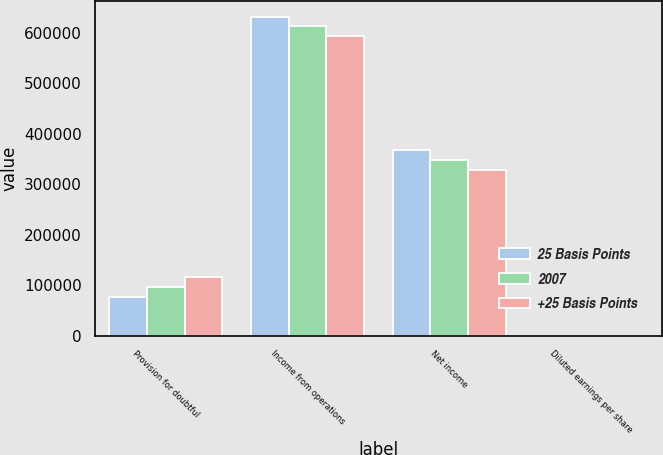Convert chart. <chart><loc_0><loc_0><loc_500><loc_500><stacked_bar_chart><ecel><fcel>Provision for doubtful<fcel>Income from operations<fcel>Net income<fcel>Diluted earnings per share<nl><fcel>25 Basis Points<fcel>77280<fcel>632361<fcel>367432<fcel>0.27<nl><fcel>2007<fcel>96461<fcel>613180<fcel>348251<fcel>0.25<nl><fcel>+25 Basis Points<fcel>115642<fcel>593999<fcel>329070<fcel>0.24<nl></chart> 